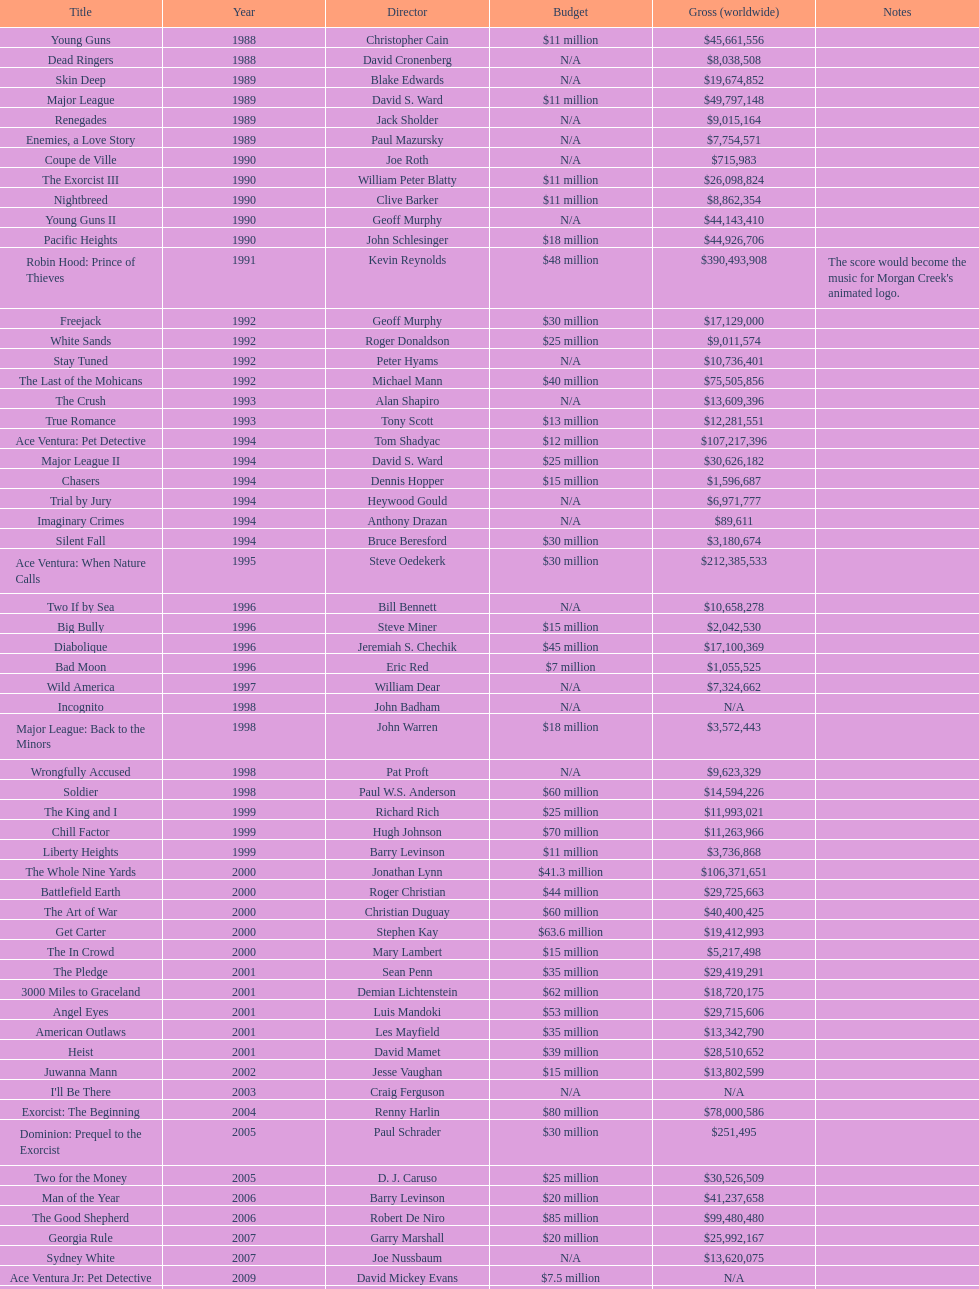Would you be able to parse every entry in this table? {'header': ['Title', 'Year', 'Director', 'Budget', 'Gross (worldwide)', 'Notes'], 'rows': [['Young Guns', '1988', 'Christopher Cain', '$11 million', '$45,661,556', ''], ['Dead Ringers', '1988', 'David Cronenberg', 'N/A', '$8,038,508', ''], ['Skin Deep', '1989', 'Blake Edwards', 'N/A', '$19,674,852', ''], ['Major League', '1989', 'David S. Ward', '$11 million', '$49,797,148', ''], ['Renegades', '1989', 'Jack Sholder', 'N/A', '$9,015,164', ''], ['Enemies, a Love Story', '1989', 'Paul Mazursky', 'N/A', '$7,754,571', ''], ['Coupe de Ville', '1990', 'Joe Roth', 'N/A', '$715,983', ''], ['The Exorcist III', '1990', 'William Peter Blatty', '$11 million', '$26,098,824', ''], ['Nightbreed', '1990', 'Clive Barker', '$11 million', '$8,862,354', ''], ['Young Guns II', '1990', 'Geoff Murphy', 'N/A', '$44,143,410', ''], ['Pacific Heights', '1990', 'John Schlesinger', '$18 million', '$44,926,706', ''], ['Robin Hood: Prince of Thieves', '1991', 'Kevin Reynolds', '$48 million', '$390,493,908', "The score would become the music for Morgan Creek's animated logo."], ['Freejack', '1992', 'Geoff Murphy', '$30 million', '$17,129,000', ''], ['White Sands', '1992', 'Roger Donaldson', '$25 million', '$9,011,574', ''], ['Stay Tuned', '1992', 'Peter Hyams', 'N/A', '$10,736,401', ''], ['The Last of the Mohicans', '1992', 'Michael Mann', '$40 million', '$75,505,856', ''], ['The Crush', '1993', 'Alan Shapiro', 'N/A', '$13,609,396', ''], ['True Romance', '1993', 'Tony Scott', '$13 million', '$12,281,551', ''], ['Ace Ventura: Pet Detective', '1994', 'Tom Shadyac', '$12 million', '$107,217,396', ''], ['Major League II', '1994', 'David S. Ward', '$25 million', '$30,626,182', ''], ['Chasers', '1994', 'Dennis Hopper', '$15 million', '$1,596,687', ''], ['Trial by Jury', '1994', 'Heywood Gould', 'N/A', '$6,971,777', ''], ['Imaginary Crimes', '1994', 'Anthony Drazan', 'N/A', '$89,611', ''], ['Silent Fall', '1994', 'Bruce Beresford', '$30 million', '$3,180,674', ''], ['Ace Ventura: When Nature Calls', '1995', 'Steve Oedekerk', '$30 million', '$212,385,533', ''], ['Two If by Sea', '1996', 'Bill Bennett', 'N/A', '$10,658,278', ''], ['Big Bully', '1996', 'Steve Miner', '$15 million', '$2,042,530', ''], ['Diabolique', '1996', 'Jeremiah S. Chechik', '$45 million', '$17,100,369', ''], ['Bad Moon', '1996', 'Eric Red', '$7 million', '$1,055,525', ''], ['Wild America', '1997', 'William Dear', 'N/A', '$7,324,662', ''], ['Incognito', '1998', 'John Badham', 'N/A', 'N/A', ''], ['Major League: Back to the Minors', '1998', 'John Warren', '$18 million', '$3,572,443', ''], ['Wrongfully Accused', '1998', 'Pat Proft', 'N/A', '$9,623,329', ''], ['Soldier', '1998', 'Paul W.S. Anderson', '$60 million', '$14,594,226', ''], ['The King and I', '1999', 'Richard Rich', '$25 million', '$11,993,021', ''], ['Chill Factor', '1999', 'Hugh Johnson', '$70 million', '$11,263,966', ''], ['Liberty Heights', '1999', 'Barry Levinson', '$11 million', '$3,736,868', ''], ['The Whole Nine Yards', '2000', 'Jonathan Lynn', '$41.3 million', '$106,371,651', ''], ['Battlefield Earth', '2000', 'Roger Christian', '$44 million', '$29,725,663', ''], ['The Art of War', '2000', 'Christian Duguay', '$60 million', '$40,400,425', ''], ['Get Carter', '2000', 'Stephen Kay', '$63.6 million', '$19,412,993', ''], ['The In Crowd', '2000', 'Mary Lambert', '$15 million', '$5,217,498', ''], ['The Pledge', '2001', 'Sean Penn', '$35 million', '$29,419,291', ''], ['3000 Miles to Graceland', '2001', 'Demian Lichtenstein', '$62 million', '$18,720,175', ''], ['Angel Eyes', '2001', 'Luis Mandoki', '$53 million', '$29,715,606', ''], ['American Outlaws', '2001', 'Les Mayfield', '$35 million', '$13,342,790', ''], ['Heist', '2001', 'David Mamet', '$39 million', '$28,510,652', ''], ['Juwanna Mann', '2002', 'Jesse Vaughan', '$15 million', '$13,802,599', ''], ["I'll Be There", '2003', 'Craig Ferguson', 'N/A', 'N/A', ''], ['Exorcist: The Beginning', '2004', 'Renny Harlin', '$80 million', '$78,000,586', ''], ['Dominion: Prequel to the Exorcist', '2005', 'Paul Schrader', '$30 million', '$251,495', ''], ['Two for the Money', '2005', 'D. J. Caruso', '$25 million', '$30,526,509', ''], ['Man of the Year', '2006', 'Barry Levinson', '$20 million', '$41,237,658', ''], ['The Good Shepherd', '2006', 'Robert De Niro', '$85 million', '$99,480,480', ''], ['Georgia Rule', '2007', 'Garry Marshall', '$20 million', '$25,992,167', ''], ['Sydney White', '2007', 'Joe Nussbaum', 'N/A', '$13,620,075', ''], ['Ace Ventura Jr: Pet Detective', '2009', 'David Mickey Evans', '$7.5 million', 'N/A', ''], ['Dream House', '2011', 'Jim Sheridan', '$50 million', '$38,502,340', ''], ['The Thing', '2011', 'Matthijs van Heijningen Jr.', '$38 million', '$27,428,670', ''], ['Tupac', '2014', 'Antoine Fuqua', '$45 million', '', '']]} Which film was produced just prior to "the pledge"? The In Crowd. 